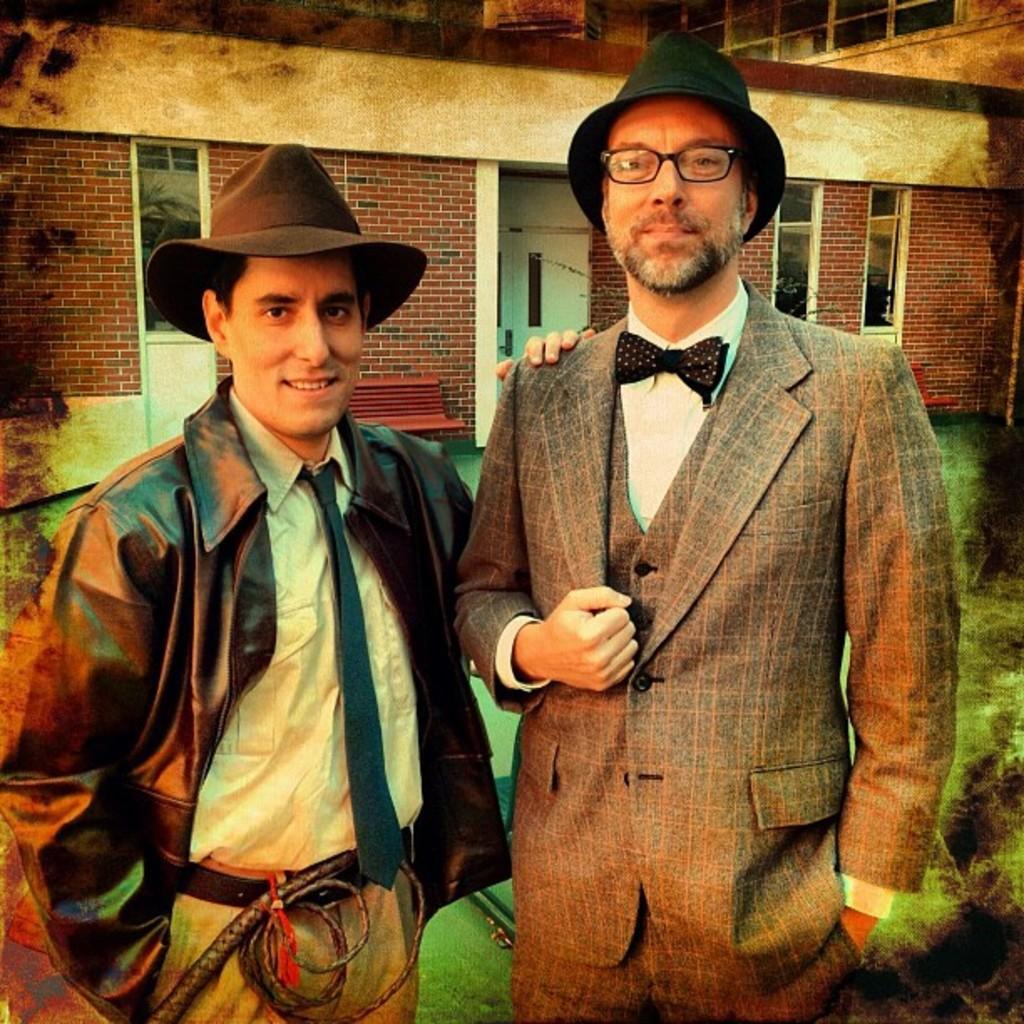In one or two sentences, can you explain what this image depicts? In this image on the right, there is a man, he wears a suit, shirt, tie, trouser and hat. On the left there is a man, he wears a jacket, shirt, tie, trouser, hat. In the background there is a building and bench. 